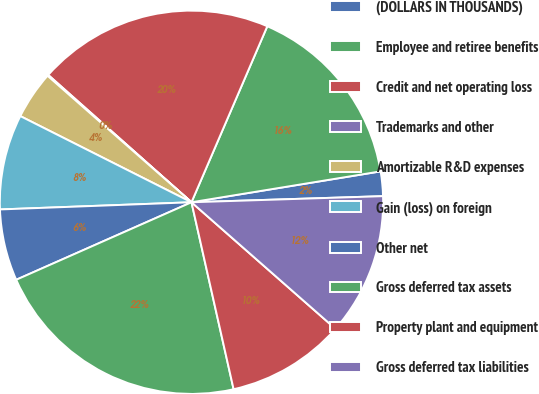Convert chart to OTSL. <chart><loc_0><loc_0><loc_500><loc_500><pie_chart><fcel>(DOLLARS IN THOUSANDS)<fcel>Employee and retiree benefits<fcel>Credit and net operating loss<fcel>Trademarks and other<fcel>Amortizable R&D expenses<fcel>Gain (loss) on foreign<fcel>Other net<fcel>Gross deferred tax assets<fcel>Property plant and equipment<fcel>Gross deferred tax liabilities<nl><fcel>2.07%<fcel>15.95%<fcel>19.91%<fcel>0.09%<fcel>4.05%<fcel>8.02%<fcel>6.03%<fcel>21.9%<fcel>10.0%<fcel>11.98%<nl></chart> 